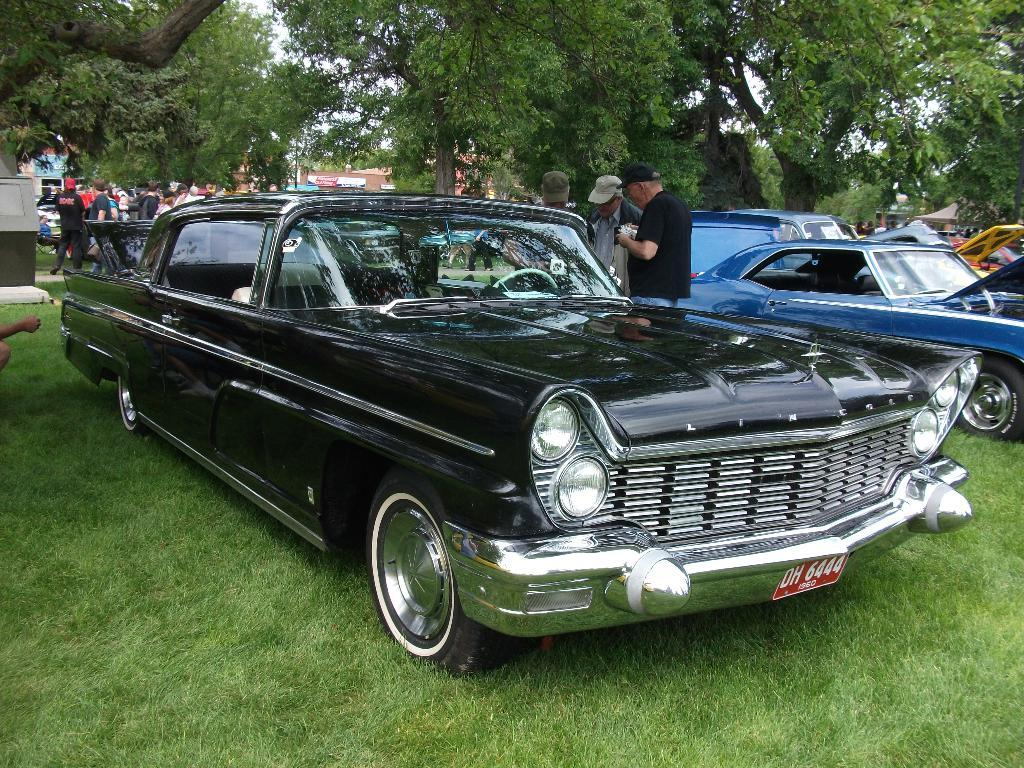What can be seen in the foreground of the picture? In the foreground of the picture, there are cars, trees, and people. Can you describe the people in the foreground? The people in the foreground are standing. What is visible in the background of the picture? In the background of the picture, there are people, cars, and buildings. Are there any ghosts visible in the picture? No, there are no ghosts present in the picture. Can you describe the weather conditions in the picture, such as the presence of sleet? The weather conditions are not mentioned in the provided facts, so it cannot be determined if there is sleet in the picture. 